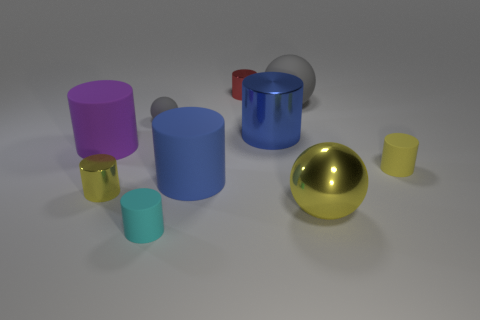Subtract all large matte spheres. How many spheres are left? 2 Subtract all cyan cylinders. How many gray spheres are left? 2 Subtract all balls. How many objects are left? 7 Subtract all gray spheres. How many spheres are left? 1 Subtract all red cylinders. Subtract all purple spheres. How many cylinders are left? 6 Subtract all small cyan cylinders. Subtract all green shiny things. How many objects are left? 9 Add 4 big shiny balls. How many big shiny balls are left? 5 Add 3 tiny yellow matte things. How many tiny yellow matte things exist? 4 Subtract 0 gray cubes. How many objects are left? 10 Subtract 1 spheres. How many spheres are left? 2 